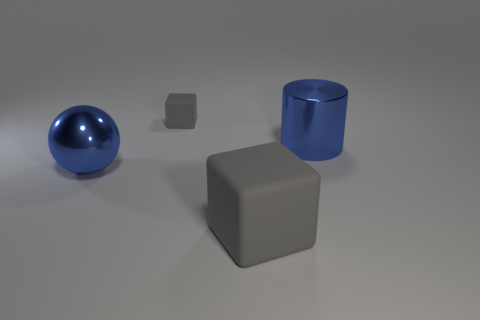Add 1 brown metal objects. How many objects exist? 5 Subtract all balls. How many objects are left? 3 Subtract 0 red cylinders. How many objects are left? 4 Subtract all tiny blue cylinders. Subtract all matte cubes. How many objects are left? 2 Add 1 gray objects. How many gray objects are left? 3 Add 3 large gray cubes. How many large gray cubes exist? 4 